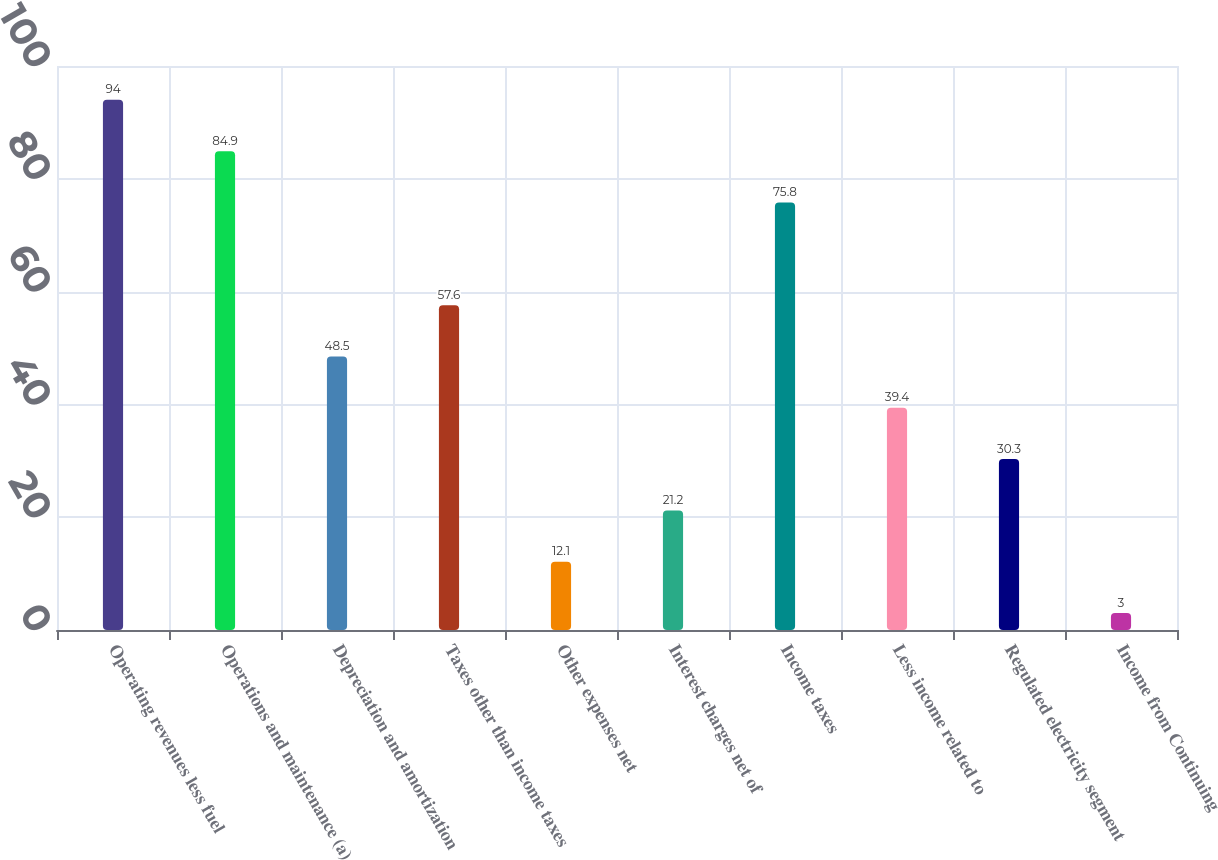Convert chart. <chart><loc_0><loc_0><loc_500><loc_500><bar_chart><fcel>Operating revenues less fuel<fcel>Operations and maintenance (a)<fcel>Depreciation and amortization<fcel>Taxes other than income taxes<fcel>Other expenses net<fcel>Interest charges net of<fcel>Income taxes<fcel>Less income related to<fcel>Regulated electricity segment<fcel>Income from Continuing<nl><fcel>94<fcel>84.9<fcel>48.5<fcel>57.6<fcel>12.1<fcel>21.2<fcel>75.8<fcel>39.4<fcel>30.3<fcel>3<nl></chart> 